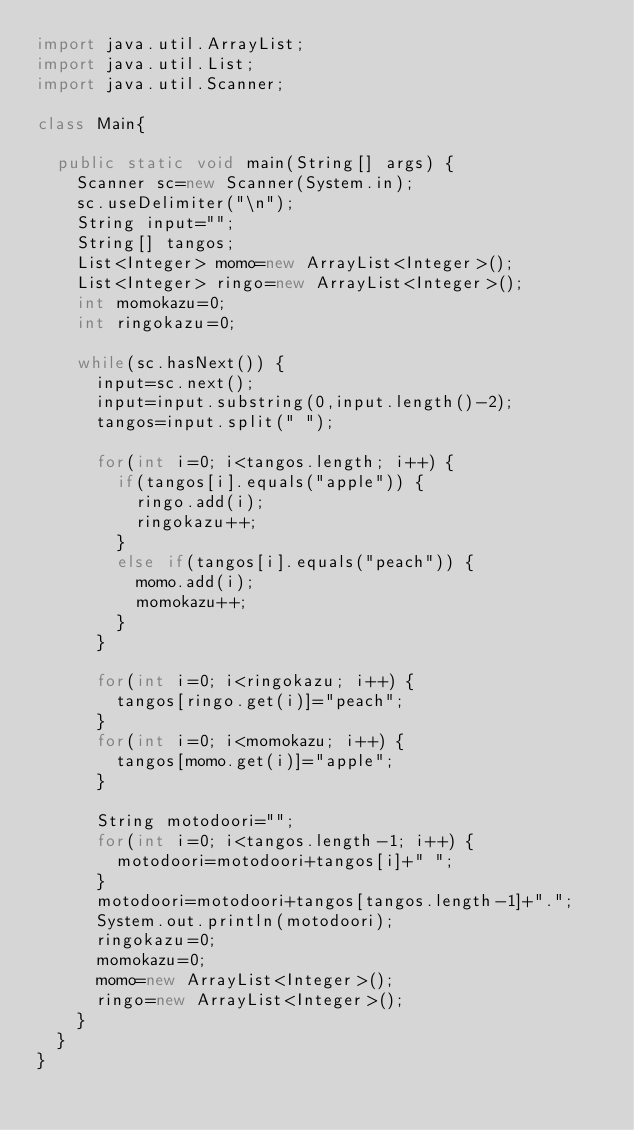Convert code to text. <code><loc_0><loc_0><loc_500><loc_500><_Java_>import java.util.ArrayList;
import java.util.List;
import java.util.Scanner;

class Main{

	public static void main(String[] args) {
		Scanner sc=new Scanner(System.in);
		sc.useDelimiter("\n");
		String input="";
		String[] tangos;
		List<Integer> momo=new ArrayList<Integer>();
		List<Integer> ringo=new ArrayList<Integer>();
		int momokazu=0;
		int ringokazu=0;

		while(sc.hasNext()) {
			input=sc.next();
			input=input.substring(0,input.length()-2);
			tangos=input.split(" ");

			for(int i=0; i<tangos.length; i++) {
				if(tangos[i].equals("apple")) {
					ringo.add(i);
					ringokazu++;
				}
				else if(tangos[i].equals("peach")) {
					momo.add(i);
					momokazu++;
				}
			}

			for(int i=0; i<ringokazu; i++) {
				tangos[ringo.get(i)]="peach";
			}
			for(int i=0; i<momokazu; i++) {
				tangos[momo.get(i)]="apple";
			}

			String motodoori="";
			for(int i=0; i<tangos.length-1; i++) {
				motodoori=motodoori+tangos[i]+" ";
			}
			motodoori=motodoori+tangos[tangos.length-1]+".";
			System.out.println(motodoori);
			ringokazu=0;
			momokazu=0;
			momo=new ArrayList<Integer>();
			ringo=new ArrayList<Integer>();
		}
	}
}
</code> 